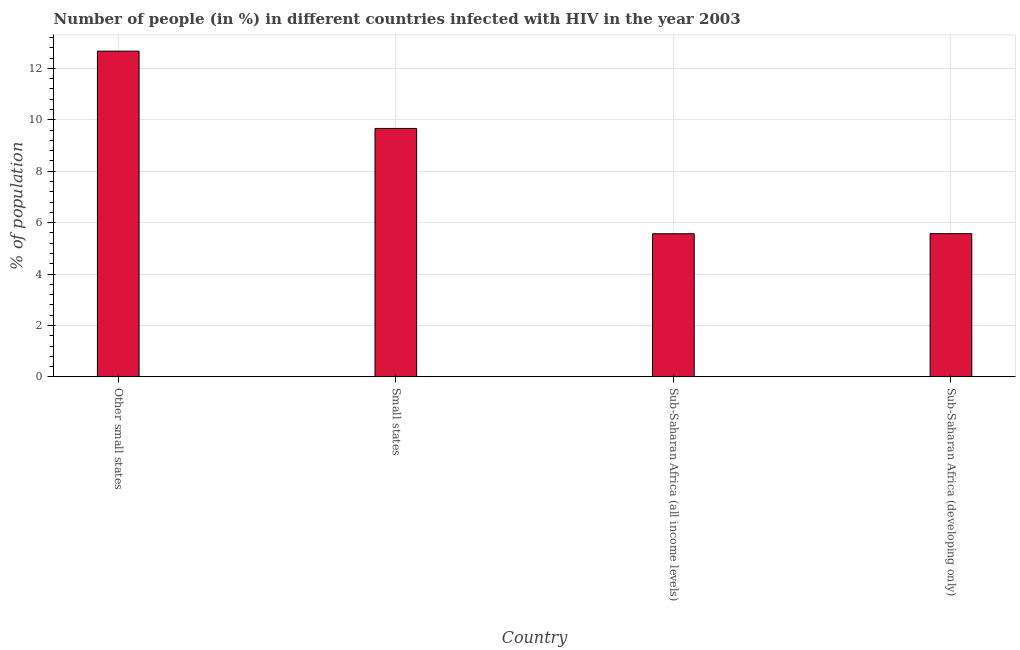Does the graph contain any zero values?
Your answer should be compact. No. What is the title of the graph?
Your response must be concise. Number of people (in %) in different countries infected with HIV in the year 2003. What is the label or title of the Y-axis?
Your response must be concise. % of population. What is the number of people infected with hiv in Sub-Saharan Africa (developing only)?
Your response must be concise. 5.57. Across all countries, what is the maximum number of people infected with hiv?
Ensure brevity in your answer.  12.67. Across all countries, what is the minimum number of people infected with hiv?
Provide a short and direct response. 5.57. In which country was the number of people infected with hiv maximum?
Your answer should be compact. Other small states. In which country was the number of people infected with hiv minimum?
Offer a very short reply. Sub-Saharan Africa (all income levels). What is the sum of the number of people infected with hiv?
Your response must be concise. 33.47. What is the difference between the number of people infected with hiv in Small states and Sub-Saharan Africa (developing only)?
Keep it short and to the point. 4.09. What is the average number of people infected with hiv per country?
Keep it short and to the point. 8.37. What is the median number of people infected with hiv?
Your answer should be very brief. 7.62. What is the ratio of the number of people infected with hiv in Small states to that in Sub-Saharan Africa (developing only)?
Your response must be concise. 1.74. Is the difference between the number of people infected with hiv in Small states and Sub-Saharan Africa (developing only) greater than the difference between any two countries?
Provide a succinct answer. No. What is the difference between the highest and the second highest number of people infected with hiv?
Make the answer very short. 3. Is the sum of the number of people infected with hiv in Sub-Saharan Africa (all income levels) and Sub-Saharan Africa (developing only) greater than the maximum number of people infected with hiv across all countries?
Ensure brevity in your answer.  No. What is the difference between the highest and the lowest number of people infected with hiv?
Your answer should be compact. 7.1. How many bars are there?
Make the answer very short. 4. Are all the bars in the graph horizontal?
Your answer should be compact. No. What is the difference between two consecutive major ticks on the Y-axis?
Offer a very short reply. 2. Are the values on the major ticks of Y-axis written in scientific E-notation?
Provide a short and direct response. No. What is the % of population of Other small states?
Your response must be concise. 12.67. What is the % of population in Small states?
Offer a terse response. 9.66. What is the % of population of Sub-Saharan Africa (all income levels)?
Your answer should be very brief. 5.57. What is the % of population in Sub-Saharan Africa (developing only)?
Offer a terse response. 5.57. What is the difference between the % of population in Other small states and Small states?
Keep it short and to the point. 3.01. What is the difference between the % of population in Other small states and Sub-Saharan Africa (all income levels)?
Offer a very short reply. 7.1. What is the difference between the % of population in Other small states and Sub-Saharan Africa (developing only)?
Your answer should be compact. 7.1. What is the difference between the % of population in Small states and Sub-Saharan Africa (all income levels)?
Give a very brief answer. 4.1. What is the difference between the % of population in Small states and Sub-Saharan Africa (developing only)?
Offer a terse response. 4.09. What is the difference between the % of population in Sub-Saharan Africa (all income levels) and Sub-Saharan Africa (developing only)?
Your answer should be very brief. -0. What is the ratio of the % of population in Other small states to that in Small states?
Keep it short and to the point. 1.31. What is the ratio of the % of population in Other small states to that in Sub-Saharan Africa (all income levels)?
Offer a very short reply. 2.28. What is the ratio of the % of population in Other small states to that in Sub-Saharan Africa (developing only)?
Offer a terse response. 2.27. What is the ratio of the % of population in Small states to that in Sub-Saharan Africa (all income levels)?
Your response must be concise. 1.74. What is the ratio of the % of population in Small states to that in Sub-Saharan Africa (developing only)?
Keep it short and to the point. 1.74. What is the ratio of the % of population in Sub-Saharan Africa (all income levels) to that in Sub-Saharan Africa (developing only)?
Offer a very short reply. 1. 